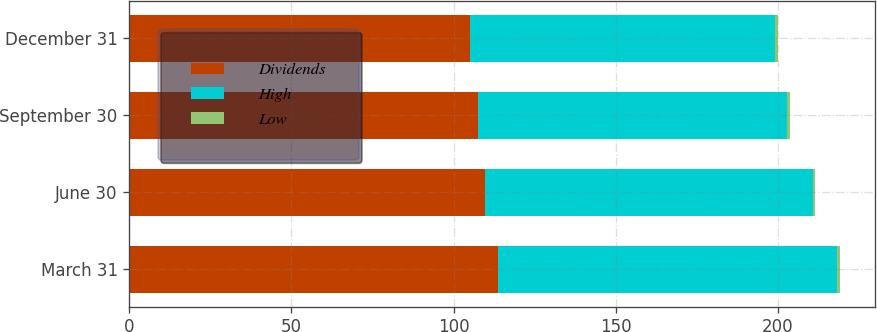<chart> <loc_0><loc_0><loc_500><loc_500><stacked_bar_chart><ecel><fcel>March 31<fcel>June 30<fcel>September 30<fcel>December 31<nl><fcel>Dividends<fcel>113.75<fcel>109.73<fcel>107.52<fcel>105.01<nl><fcel>High<fcel>104.62<fcel>101.03<fcel>95.45<fcel>94.15<nl><fcel>Low<fcel>0.78<fcel>0.78<fcel>0.78<fcel>0.81<nl></chart> 